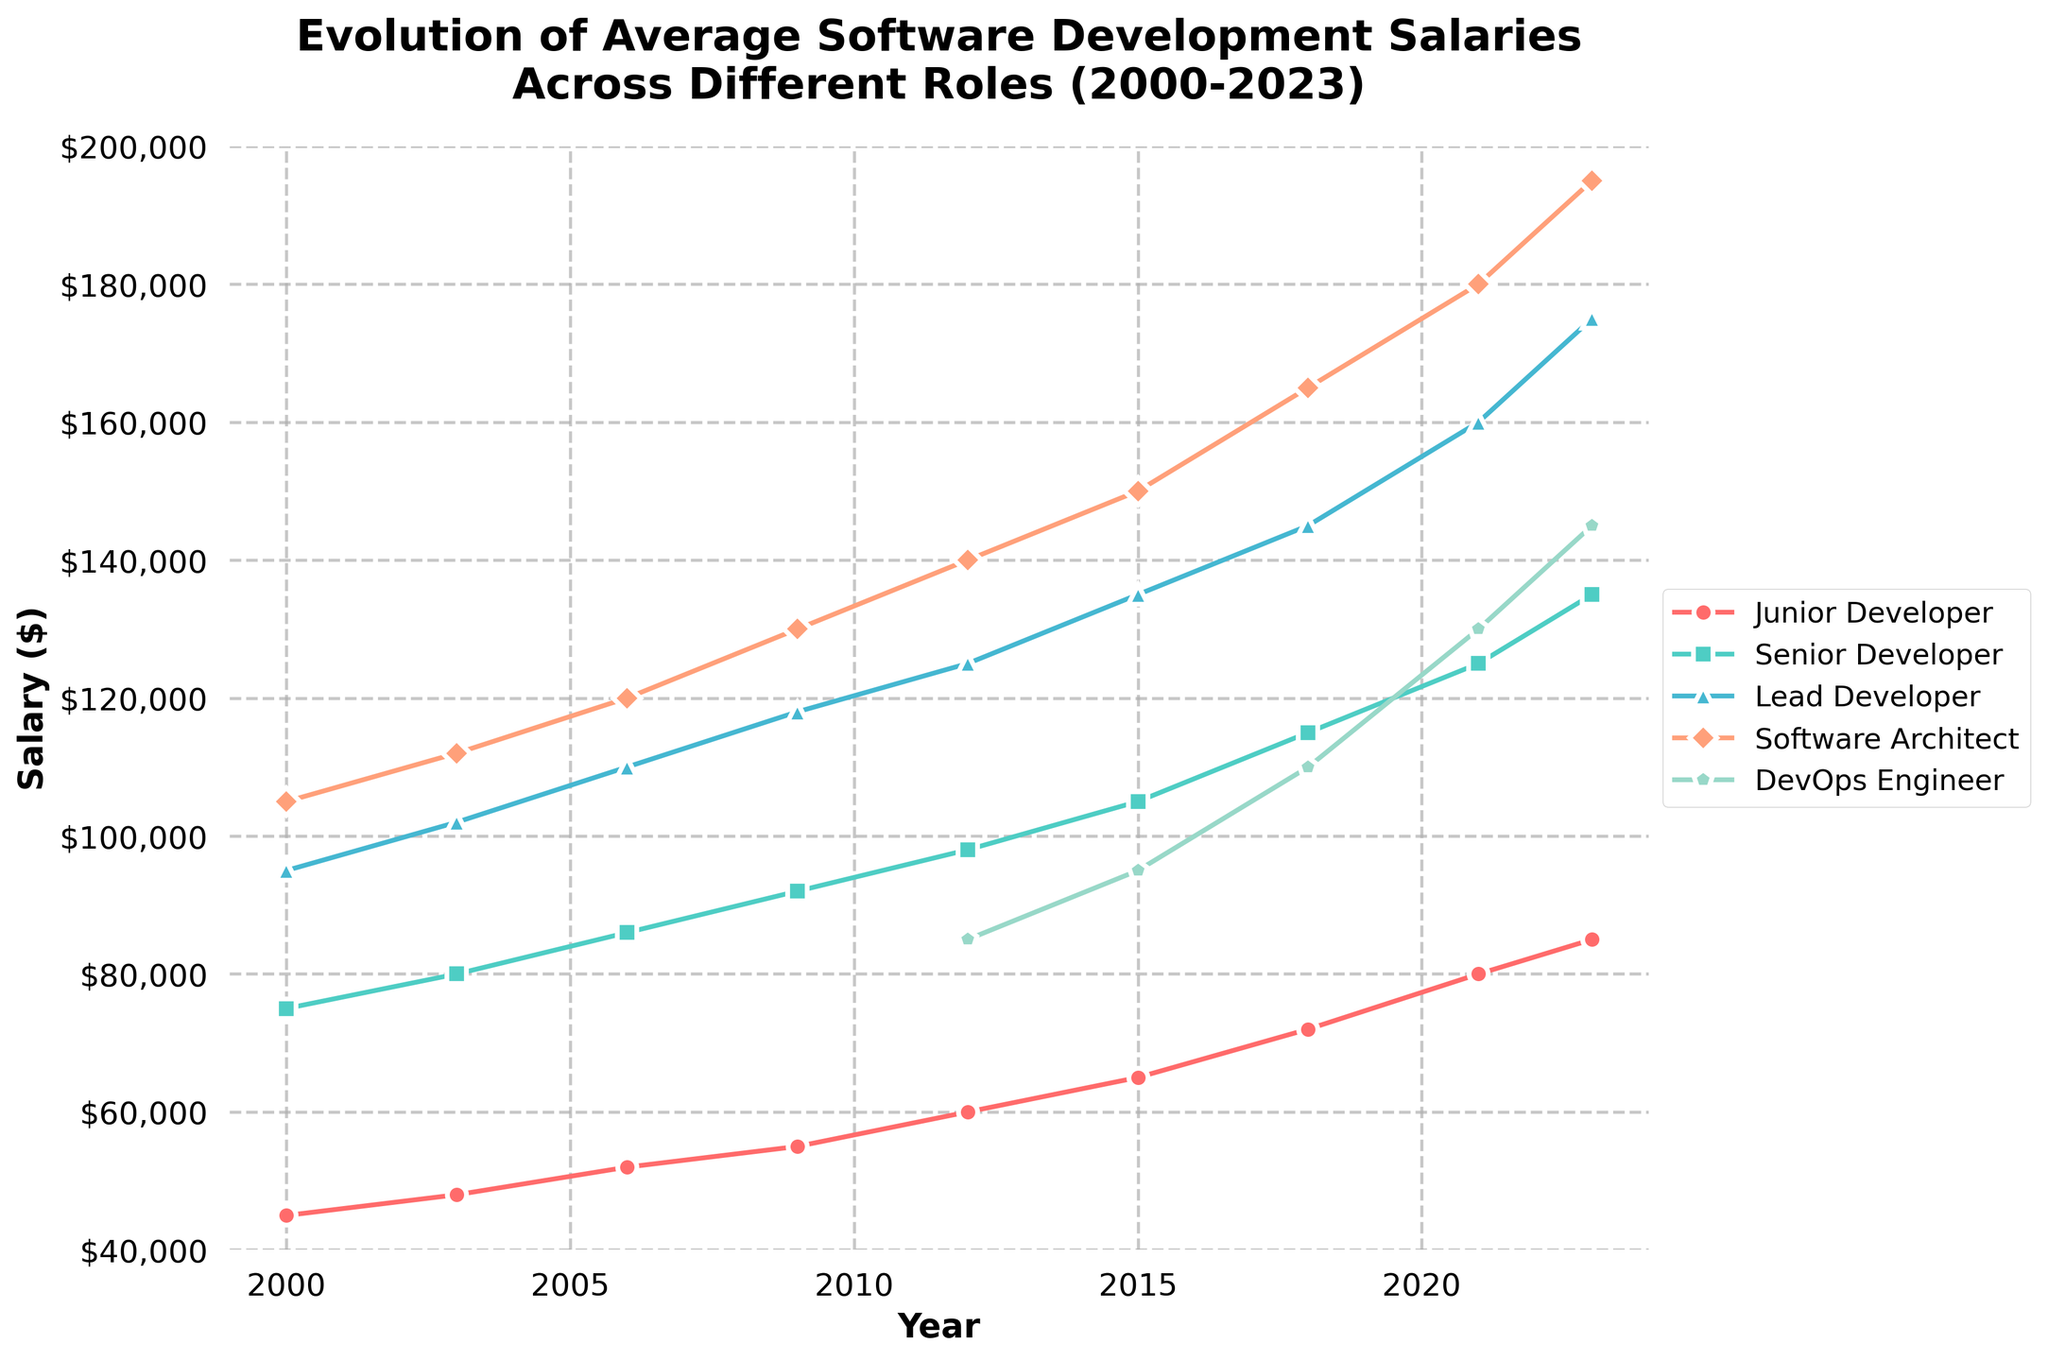What was the salary for a Lead Developer in 2009? First, locate the year 2009 on the x-axis. Then, follow vertically to intersect with the Lead Developer's line, which is marked with a specific color. The left y-axis will show the corresponding value.
Answer: $118,000 Which role saw the highest salary increase from 2012 to 2023? Find the salaries for each role in both 2012 and 2023. Calculate the difference for each role over this period by subtracting the 2012 salary from the 2023 salary. The role with the highest difference is the one with the greatest increase. Detailed steps: 
Junior Developer: 85,000 - 60,000 = 25,000 
Senior Developer: 135,000 - 98,000 = 37,000 
Lead Developer: 175,000 - 125,000 = 50,000 
Software Architect: 195,000 - 140,000 = 55,000 
DevOps Engineer: 145,000 - 85,000 (note DevOps appears from 2012) = 60,000 
DevOps Engineer has the highest increase.
Answer: DevOps Engineer What color represents the average salary of a Senior Developer? Identify the color of the line plot corresponding to the 'Senior Developer' label on the legend box. The figure legend should show the color next to each role.
Answer: Green How does the average salary for DevOps Engineers compare to Junior Developers in 2018? Locate the year 2018 on the x-axis and find the points where 'DevOps Engineers' and 'Junior Developers' lines intersect. Compare their corresponding y-axis values to see the difference. DevOps Engineers: $110,000; Junior Developers: $72,000. Detailed comparison: 110,000 > 72,000.
Answer: Higher By how much did the salary for Software Architects increase from 2006 to 2023? Find the salary for Software Architects in 2006 and 2023 by locating the years on the x-axis and following vertically to the Software Architect line. Subtract the 2006 value from the 2023 value. Detailed steps: 195,000 (2023) - 120,000 (2006) = 75,000.
Answer: $75,000 Which role had the highest salary in the year 2023? Find the year 2023 on the x-axis and look at the highest point on the y-axis intersected by any of the role lines. Check the legend to identify which role corresponds to that highest point.
Answer: Software Architect What trend can you observe in the salary for Junior Developers from 2000 to 2023? Follow the line for Junior Developers from the beginning year to the ending year. Observe if the line directionally increases, decreases, or remains constant. The line continually rises, indicating an increasing trend over time.
Answer: Increasing Between 2000 and 2012, which role had the least salary increase? Find the salaries for each role in both 2000 and 2012. Calculate the increment by subtracting the 2000 value from the 2012 value for each role. Compare the differences and identify the smallest increase. Detailed steps: 
Junior Developer: 60,000 - 45,000 = 15,000 
Senior Developer: 98,000 - 75,000 = 23,000 
Lead Developer: 125,000 - 95,000 = 30,000 
Software Architect: 140,000 - 105,000 = 35,000 
(N/A for DevOps Engineer is introduced in 2012)
Answer: Junior Developer 